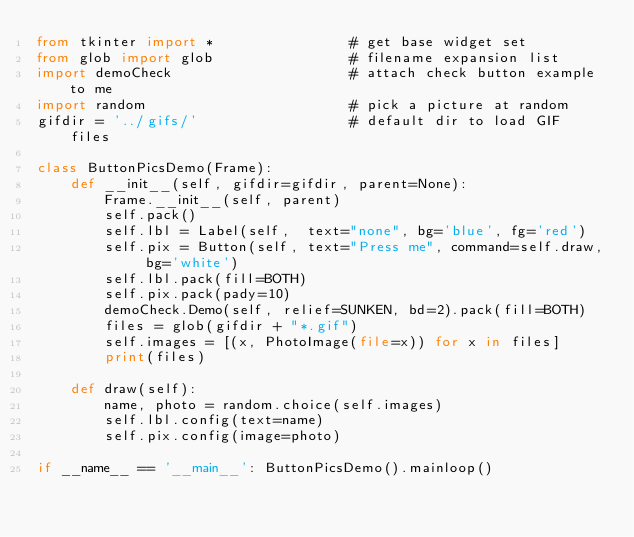Convert code to text. <code><loc_0><loc_0><loc_500><loc_500><_Python_>from tkinter import *                # get base widget set
from glob import glob                # filename expansion list
import demoCheck                     # attach check button example to me
import random                        # pick a picture at random
gifdir = '../gifs/'                  # default dir to load GIF files

class ButtonPicsDemo(Frame):
    def __init__(self, gifdir=gifdir, parent=None):
        Frame.__init__(self, parent)
        self.pack()
        self.lbl = Label(self,  text="none", bg='blue', fg='red')
        self.pix = Button(self, text="Press me", command=self.draw, bg='white')
        self.lbl.pack(fill=BOTH)
        self.pix.pack(pady=10)
        demoCheck.Demo(self, relief=SUNKEN, bd=2).pack(fill=BOTH)
        files = glob(gifdir + "*.gif")
        self.images = [(x, PhotoImage(file=x)) for x in files]
        print(files)

    def draw(self):
        name, photo = random.choice(self.images)
        self.lbl.config(text=name)
        self.pix.config(image=photo)

if __name__ == '__main__': ButtonPicsDemo().mainloop()
</code> 